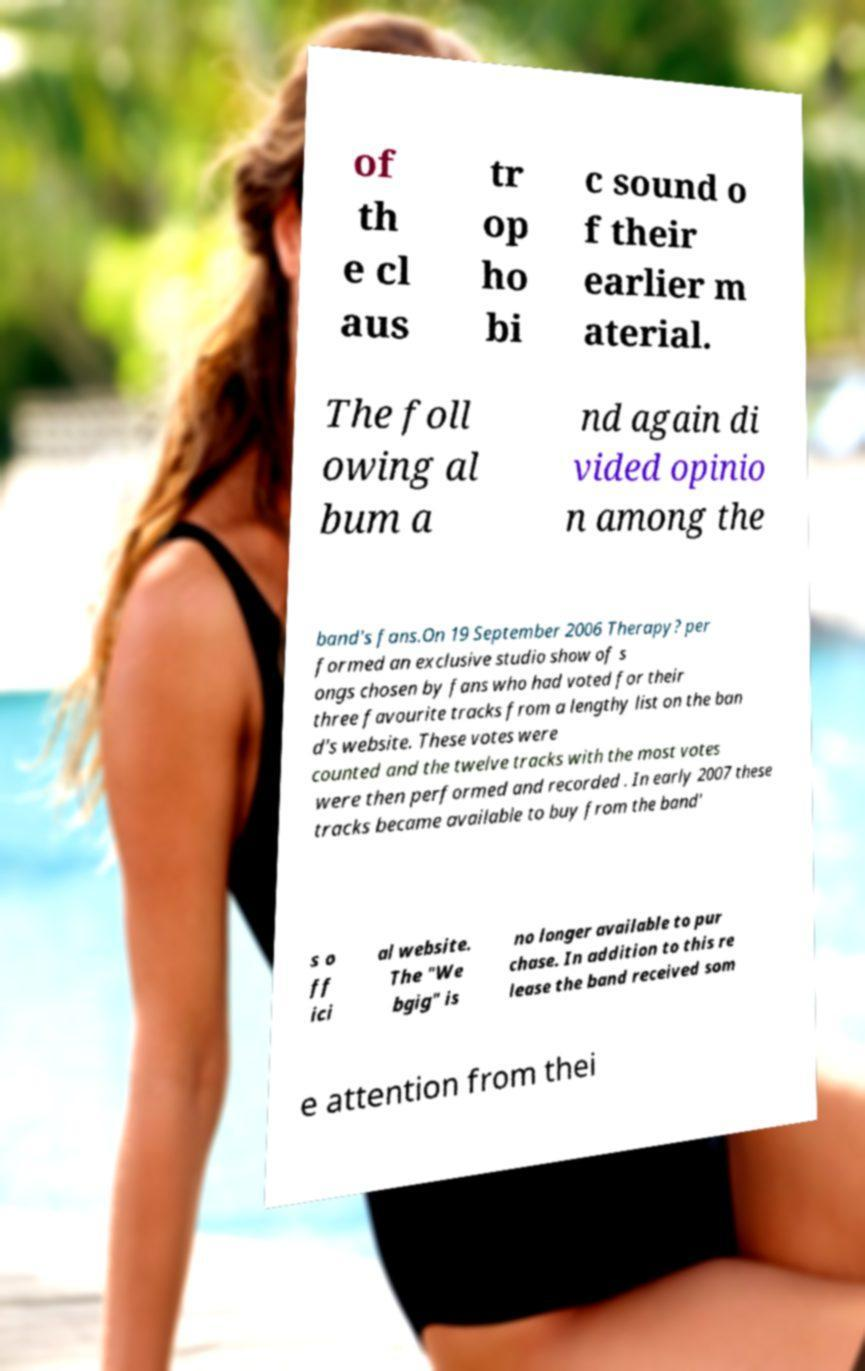Can you accurately transcribe the text from the provided image for me? of th e cl aus tr op ho bi c sound o f their earlier m aterial. The foll owing al bum a nd again di vided opinio n among the band's fans.On 19 September 2006 Therapy? per formed an exclusive studio show of s ongs chosen by fans who had voted for their three favourite tracks from a lengthy list on the ban d's website. These votes were counted and the twelve tracks with the most votes were then performed and recorded . In early 2007 these tracks became available to buy from the band' s o ff ici al website. The "We bgig" is no longer available to pur chase. In addition to this re lease the band received som e attention from thei 